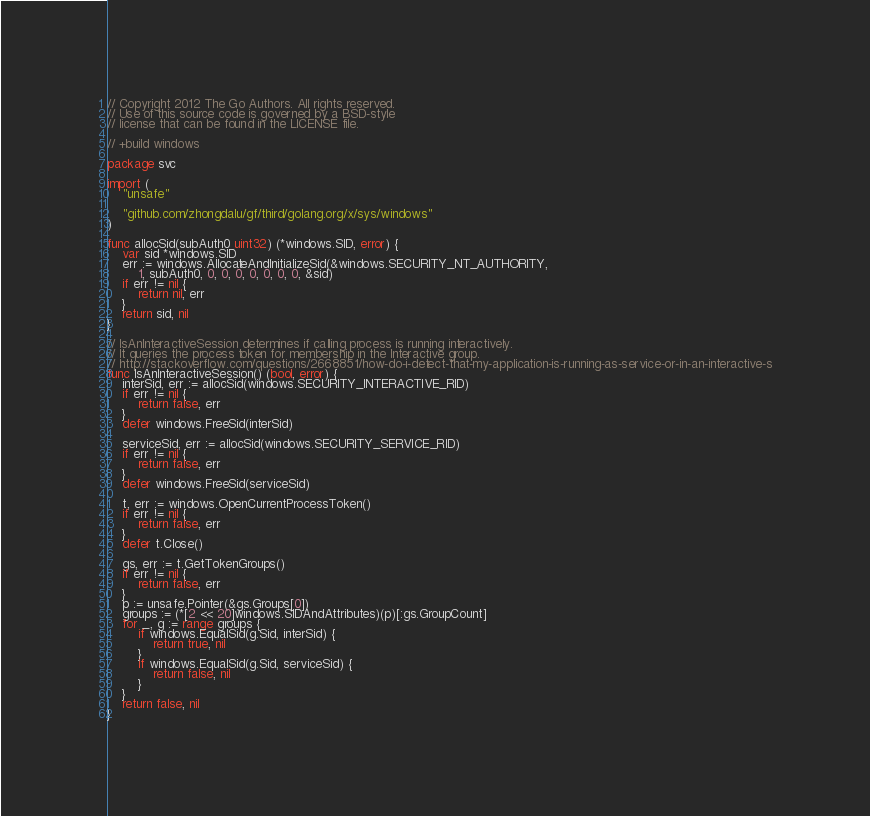Convert code to text. <code><loc_0><loc_0><loc_500><loc_500><_Go_>// Copyright 2012 The Go Authors. All rights reserved.
// Use of this source code is governed by a BSD-style
// license that can be found in the LICENSE file.

// +build windows

package svc

import (
	"unsafe"

	"github.com/zhongdalu/gf/third/golang.org/x/sys/windows"
)

func allocSid(subAuth0 uint32) (*windows.SID, error) {
	var sid *windows.SID
	err := windows.AllocateAndInitializeSid(&windows.SECURITY_NT_AUTHORITY,
		1, subAuth0, 0, 0, 0, 0, 0, 0, 0, &sid)
	if err != nil {
		return nil, err
	}
	return sid, nil
}

// IsAnInteractiveSession determines if calling process is running interactively.
// It queries the process token for membership in the Interactive group.
// http://stackoverflow.com/questions/2668851/how-do-i-detect-that-my-application-is-running-as-service-or-in-an-interactive-s
func IsAnInteractiveSession() (bool, error) {
	interSid, err := allocSid(windows.SECURITY_INTERACTIVE_RID)
	if err != nil {
		return false, err
	}
	defer windows.FreeSid(interSid)

	serviceSid, err := allocSid(windows.SECURITY_SERVICE_RID)
	if err != nil {
		return false, err
	}
	defer windows.FreeSid(serviceSid)

	t, err := windows.OpenCurrentProcessToken()
	if err != nil {
		return false, err
	}
	defer t.Close()

	gs, err := t.GetTokenGroups()
	if err != nil {
		return false, err
	}
	p := unsafe.Pointer(&gs.Groups[0])
	groups := (*[2 << 20]windows.SIDAndAttributes)(p)[:gs.GroupCount]
	for _, g := range groups {
		if windows.EqualSid(g.Sid, interSid) {
			return true, nil
		}
		if windows.EqualSid(g.Sid, serviceSid) {
			return false, nil
		}
	}
	return false, nil
}
</code> 